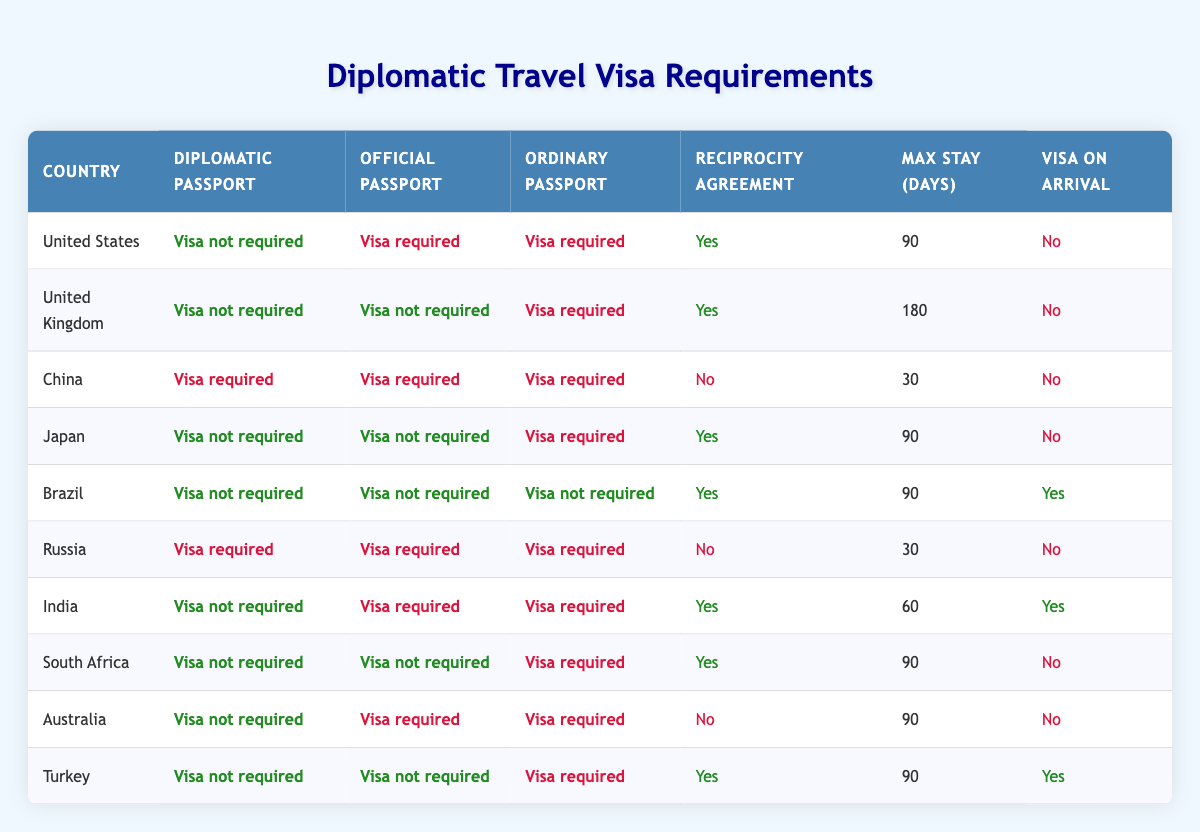What are the visa requirements for diplomatic passports for travel to the United Kingdom? According to the table, for diplomatic passports traveling to the United Kingdom, a visa is not required. This information is directly taken from the visa requirements listed for that country.
Answer: Visa not required How many countries do not require a visa for ordinary passport holders? By reviewing the table, we notice that Brazil, South Africa, and Turkey do not require a visa for ordinary passport holders. Thus, there are three such countries.
Answer: 3 Is there a reciprocity agreement required for travel to China? The table indicates that for China, there is no reciprocity agreement in place, which is marked as false in the corresponding column.
Answer: No What is the maximum stay allowed in India for diplomatic passport holders? According to the table, for diplomatic passport holders going to India, the maximum stay allowed is 60 days. This value can be found in the respective row for India under the "Max Stay (Days)" column.
Answer: 60 days Which countries allow visa on arrival for ordinary passport holders? The table lists Brazil and Turkey as the countries that allow visa on arrival for ordinary passport holders. This information can be found in the "Visa on Arrival" column for these specific countries.
Answer: Brazil, Turkey For how many days can one stay in the United States with a diplomatic passport? The entry for the United States shows a maximum stay of 90 days for diplomatic passport holders, directly mentioned in the corresponding row under the "Max Stay (Days)" column.
Answer: 90 days Do official passport holders need a visa for travel to Australia? The table shows that official passport holders do require a visa to enter Australia, as indicated in the appropriate row for that country.
Answer: Yes Which passport type requires a visa for travel to Russia, along with the maximum stay duration? Reviewing the table, we see that all passport types (diplomatic, official, and ordinary) require a visa to travel to Russia, with a maximum stay of 30 days. Therefore, this applies to all types of passports for Russia.
Answer: All passport types; 30 days How many countries in the table do not require a visa for diplomatic and official passport holders? Examining the data, we see that Brazil and Turkey do not require a visa for both diplomatic and official passport holders. Thus, there are two countries fitting this criterion.
Answer: 2 